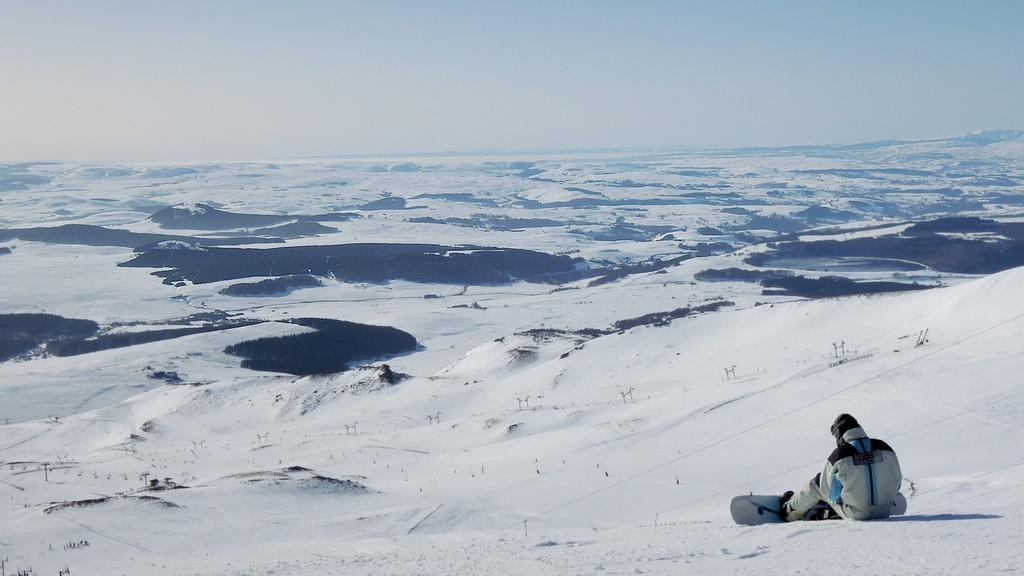Describe this image in one or two sentences. There is a person sitting on the snow and wore snowboard. In the background we can see snow and sky. 